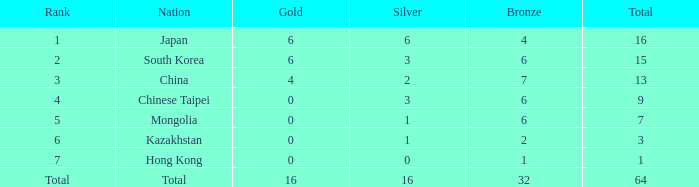Which Bronze is the lowest one that has a Rank of 3, and a Silver smaller than 2? None. 